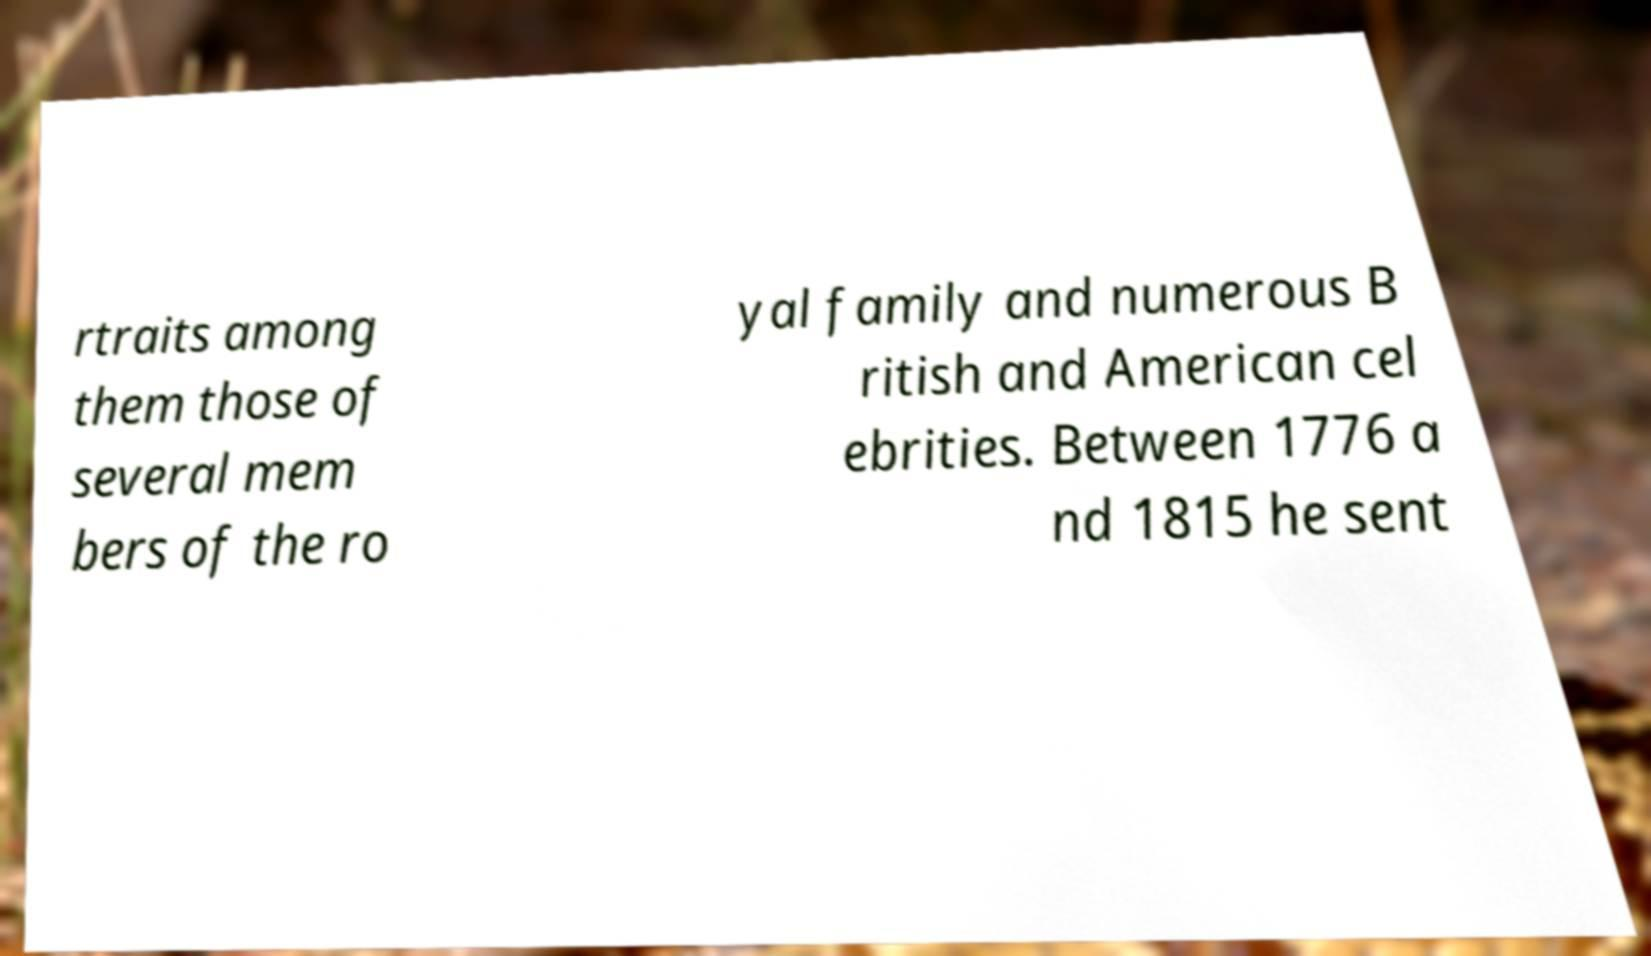There's text embedded in this image that I need extracted. Can you transcribe it verbatim? rtraits among them those of several mem bers of the ro yal family and numerous B ritish and American cel ebrities. Between 1776 a nd 1815 he sent 